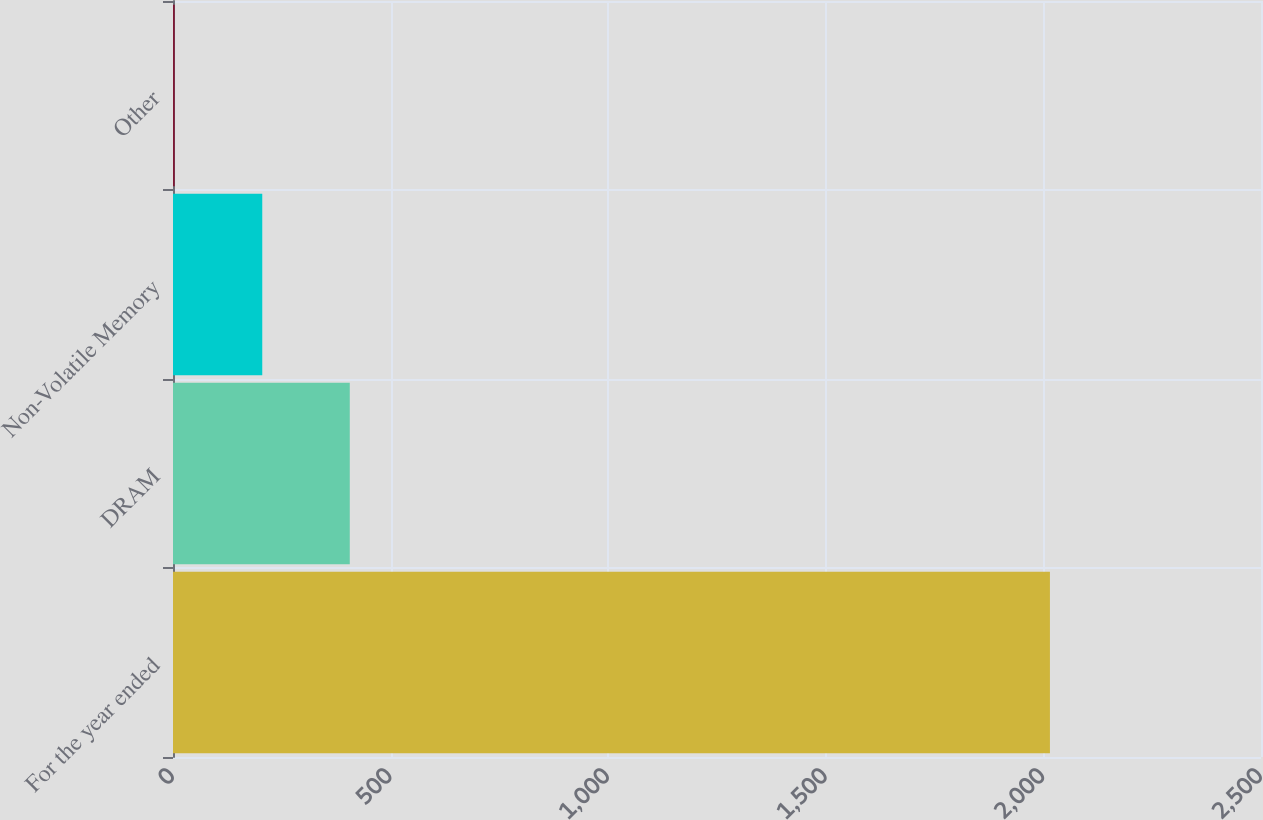<chart> <loc_0><loc_0><loc_500><loc_500><bar_chart><fcel>For the year ended<fcel>DRAM<fcel>Non-Volatile Memory<fcel>Other<nl><fcel>2015<fcel>406.2<fcel>205.1<fcel>4<nl></chart> 